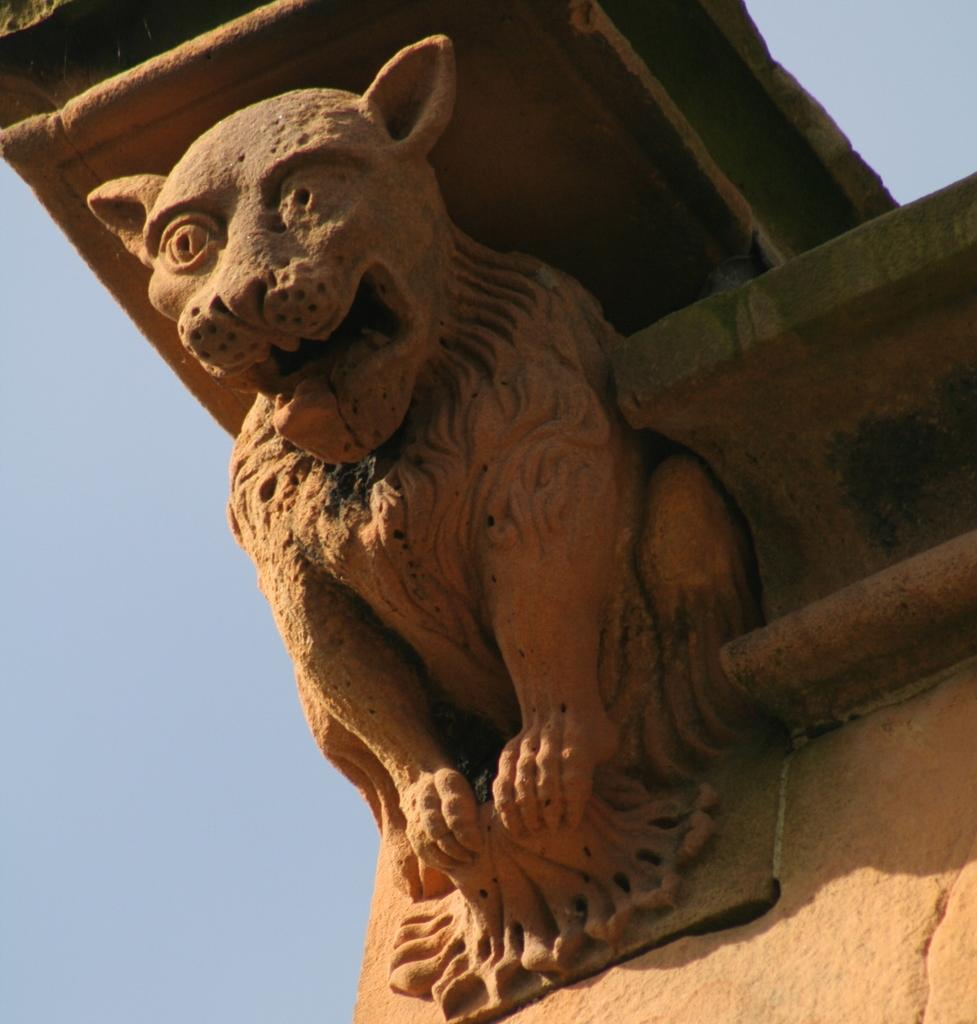What is the main subject of the image? There is a statue of an animal in the image. Can you describe the statue's appearance? The specific appearance of the statue cannot be determined from the provided facts. What can be seen in the background of the image? The sky in the background is blue. Are there any fans visible in the image? There is no mention of fans in the provided facts, so we cannot determine if any are present in the image. Can you see any fairies flying around the statue in the image? There is no mention of fairies in the provided facts, so we cannot determine if any are present in the image. 